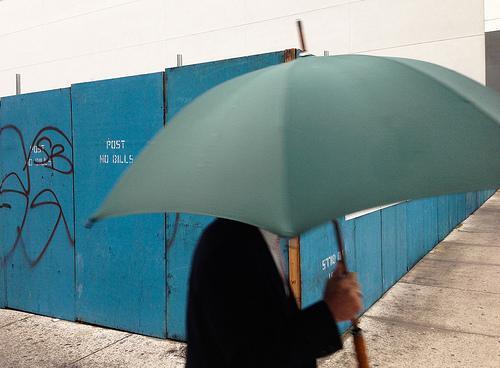How many people on the sidewalk?
Give a very brief answer. 1. 